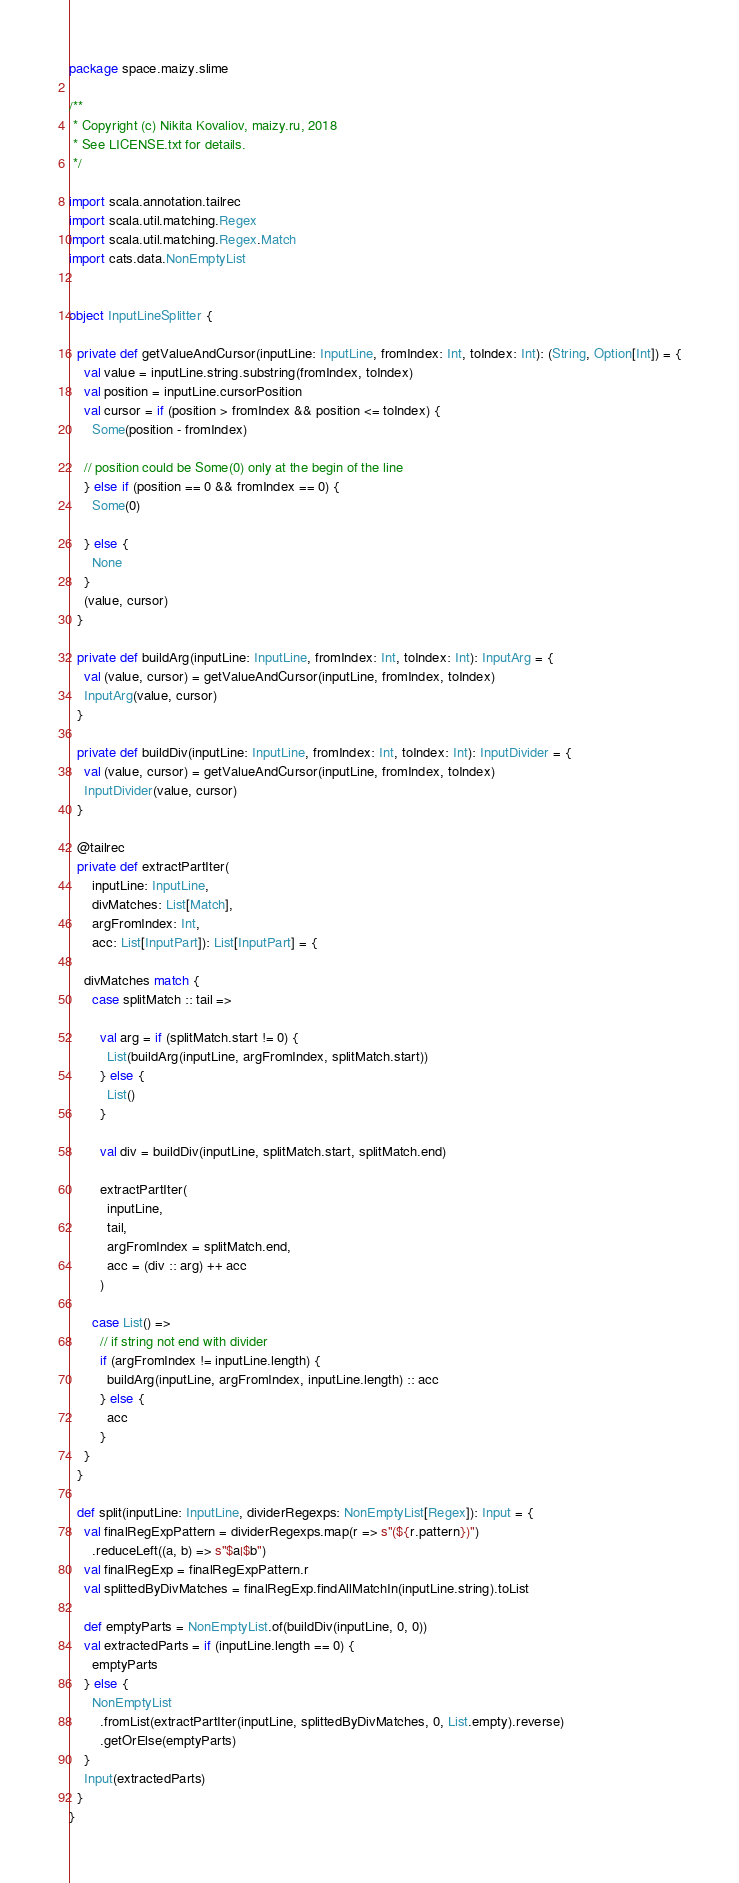<code> <loc_0><loc_0><loc_500><loc_500><_Scala_>package space.maizy.slime

/**
 * Copyright (c) Nikita Kovaliov, maizy.ru, 2018
 * See LICENSE.txt for details.
 */

import scala.annotation.tailrec
import scala.util.matching.Regex
import scala.util.matching.Regex.Match
import cats.data.NonEmptyList


object InputLineSplitter {

  private def getValueAndCursor(inputLine: InputLine, fromIndex: Int, toIndex: Int): (String, Option[Int]) = {
    val value = inputLine.string.substring(fromIndex, toIndex)
    val position = inputLine.cursorPosition
    val cursor = if (position > fromIndex && position <= toIndex) {
      Some(position - fromIndex)

    // position could be Some(0) only at the begin of the line
    } else if (position == 0 && fromIndex == 0) {
      Some(0)

    } else {
      None
    }
    (value, cursor)
  }

  private def buildArg(inputLine: InputLine, fromIndex: Int, toIndex: Int): InputArg = {
    val (value, cursor) = getValueAndCursor(inputLine, fromIndex, toIndex)
    InputArg(value, cursor)
  }

  private def buildDiv(inputLine: InputLine, fromIndex: Int, toIndex: Int): InputDivider = {
    val (value, cursor) = getValueAndCursor(inputLine, fromIndex, toIndex)
    InputDivider(value, cursor)
  }

  @tailrec
  private def extractPartIter(
      inputLine: InputLine,
      divMatches: List[Match],
      argFromIndex: Int,
      acc: List[InputPart]): List[InputPart] = {

    divMatches match {
      case splitMatch :: tail =>

        val arg = if (splitMatch.start != 0) {
          List(buildArg(inputLine, argFromIndex, splitMatch.start))
        } else {
          List()
        }

        val div = buildDiv(inputLine, splitMatch.start, splitMatch.end)

        extractPartIter(
          inputLine,
          tail,
          argFromIndex = splitMatch.end,
          acc = (div :: arg) ++ acc
        )

      case List() =>
        // if string not end with divider
        if (argFromIndex != inputLine.length) {
          buildArg(inputLine, argFromIndex, inputLine.length) :: acc
        } else {
          acc
        }
    }
  }

  def split(inputLine: InputLine, dividerRegexps: NonEmptyList[Regex]): Input = {
    val finalRegExpPattern = dividerRegexps.map(r => s"(${r.pattern})")
      .reduceLeft((a, b) => s"$a|$b")
    val finalRegExp = finalRegExpPattern.r
    val splittedByDivMatches = finalRegExp.findAllMatchIn(inputLine.string).toList

    def emptyParts = NonEmptyList.of(buildDiv(inputLine, 0, 0))
    val extractedParts = if (inputLine.length == 0) {
      emptyParts
    } else {
      NonEmptyList
        .fromList(extractPartIter(inputLine, splittedByDivMatches, 0, List.empty).reverse)
        .getOrElse(emptyParts)
    }
    Input(extractedParts)
  }
}
</code> 